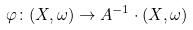<formula> <loc_0><loc_0><loc_500><loc_500>\varphi \colon ( X , \omega ) \to A ^ { - 1 } \cdot ( X , \omega )</formula> 